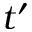Convert formula to latex. <formula><loc_0><loc_0><loc_500><loc_500>t ^ { \prime }</formula> 